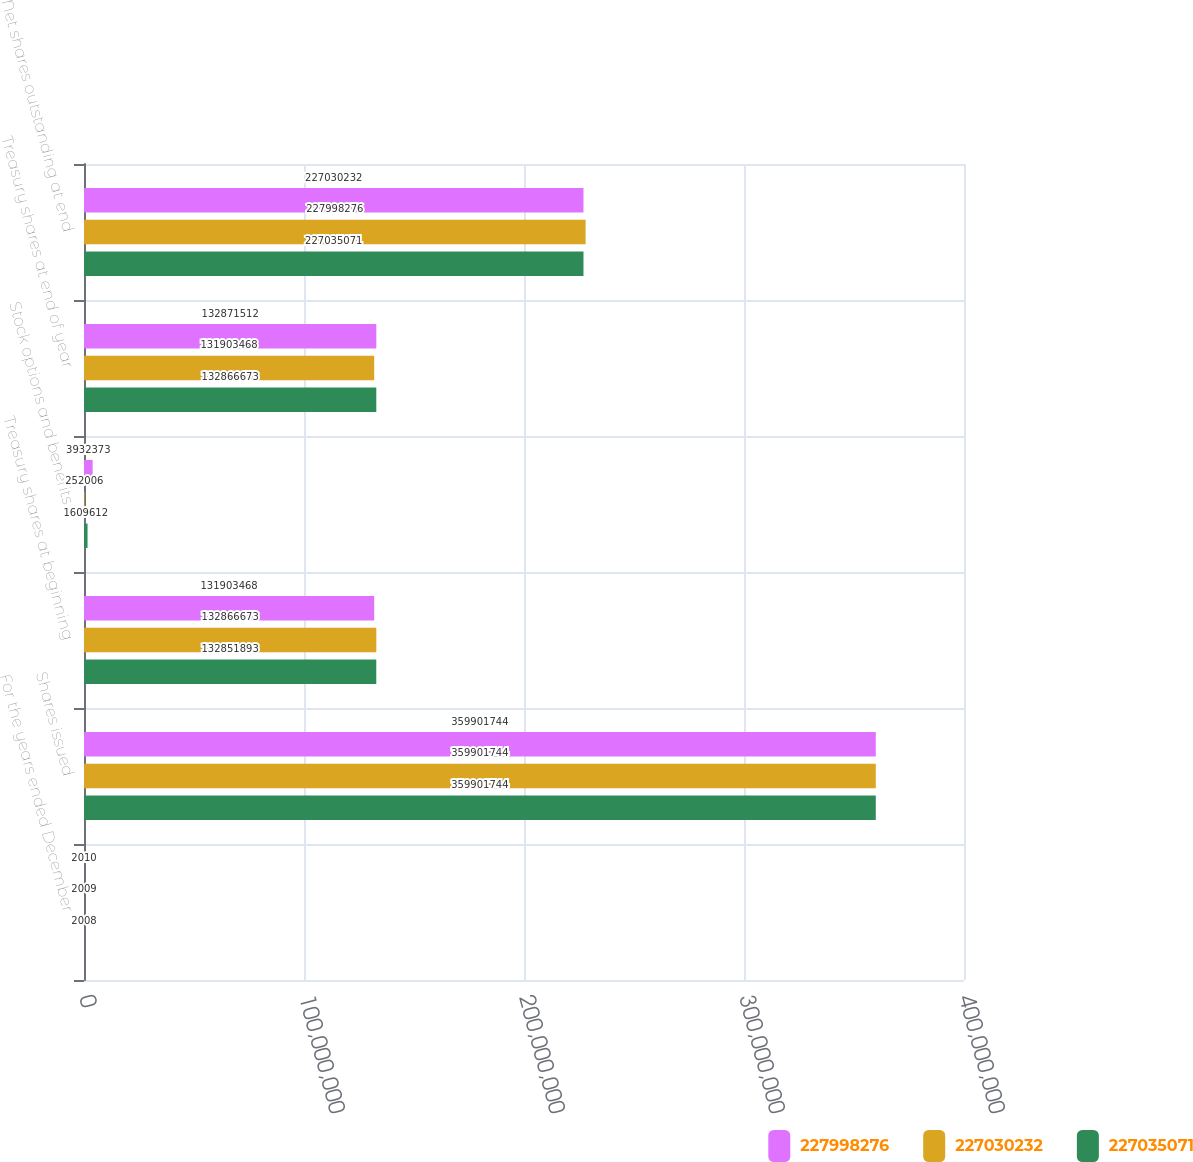<chart> <loc_0><loc_0><loc_500><loc_500><stacked_bar_chart><ecel><fcel>For the years ended December<fcel>Shares issued<fcel>Treasury shares at beginning<fcel>Stock options and benefits<fcel>Treasury shares at end of year<fcel>Net shares outstanding at end<nl><fcel>2.27998e+08<fcel>2010<fcel>3.59902e+08<fcel>1.31903e+08<fcel>3.93237e+06<fcel>1.32872e+08<fcel>2.2703e+08<nl><fcel>2.2703e+08<fcel>2009<fcel>3.59902e+08<fcel>1.32867e+08<fcel>252006<fcel>1.31903e+08<fcel>2.27998e+08<nl><fcel>2.27035e+08<fcel>2008<fcel>3.59902e+08<fcel>1.32852e+08<fcel>1.60961e+06<fcel>1.32867e+08<fcel>2.27035e+08<nl></chart> 